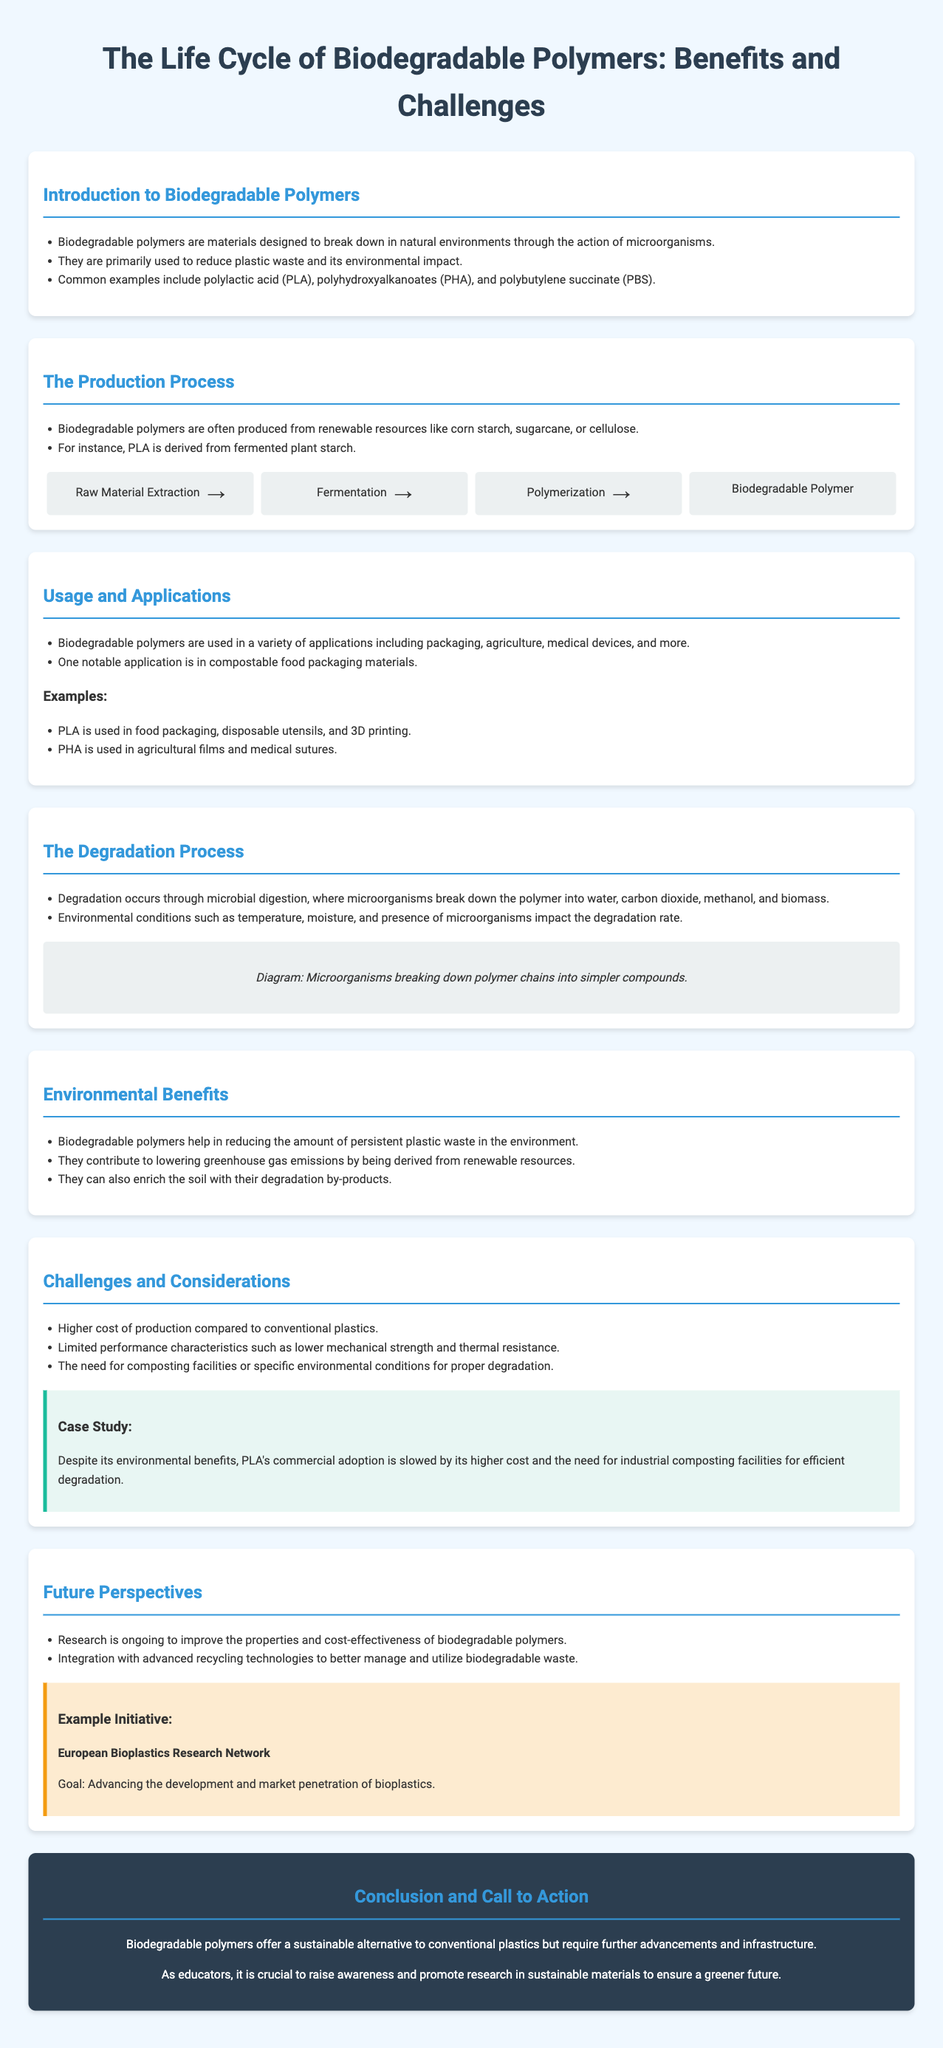What are biodegradable polymers designed to do? Biodegradable polymers are designed to break down in natural environments through the action of microorganisms.
Answer: Break down What is the primary use of biodegradable polymers? They are primarily used to reduce plastic waste and its environmental impact.
Answer: Reduce plastic waste Which renewable resource is PLA derived from? PLA is derived from fermented plant starch.
Answer: Plant starch What impact do biodegradable polymers have on greenhouse gas emissions? They contribute to lowering greenhouse gas emissions by being derived from renewable resources.
Answer: Lowering Name one notable application of biodegradable polymers. One notable application is in compostable food packaging materials.
Answer: Compostable food packaging What is a major challenge for the commercial adoption of PLA? A major challenge is its higher cost and the need for industrial composting facilities for efficient degradation.
Answer: Higher cost What is the goal of the European Bioplastics Research Network? The goal is to advance the development and market penetration of bioplastics.
Answer: Advance development How is degradation of biodegradable polymers achieved? Degradation occurs through microbial digestion.
Answer: Microbial digestion 